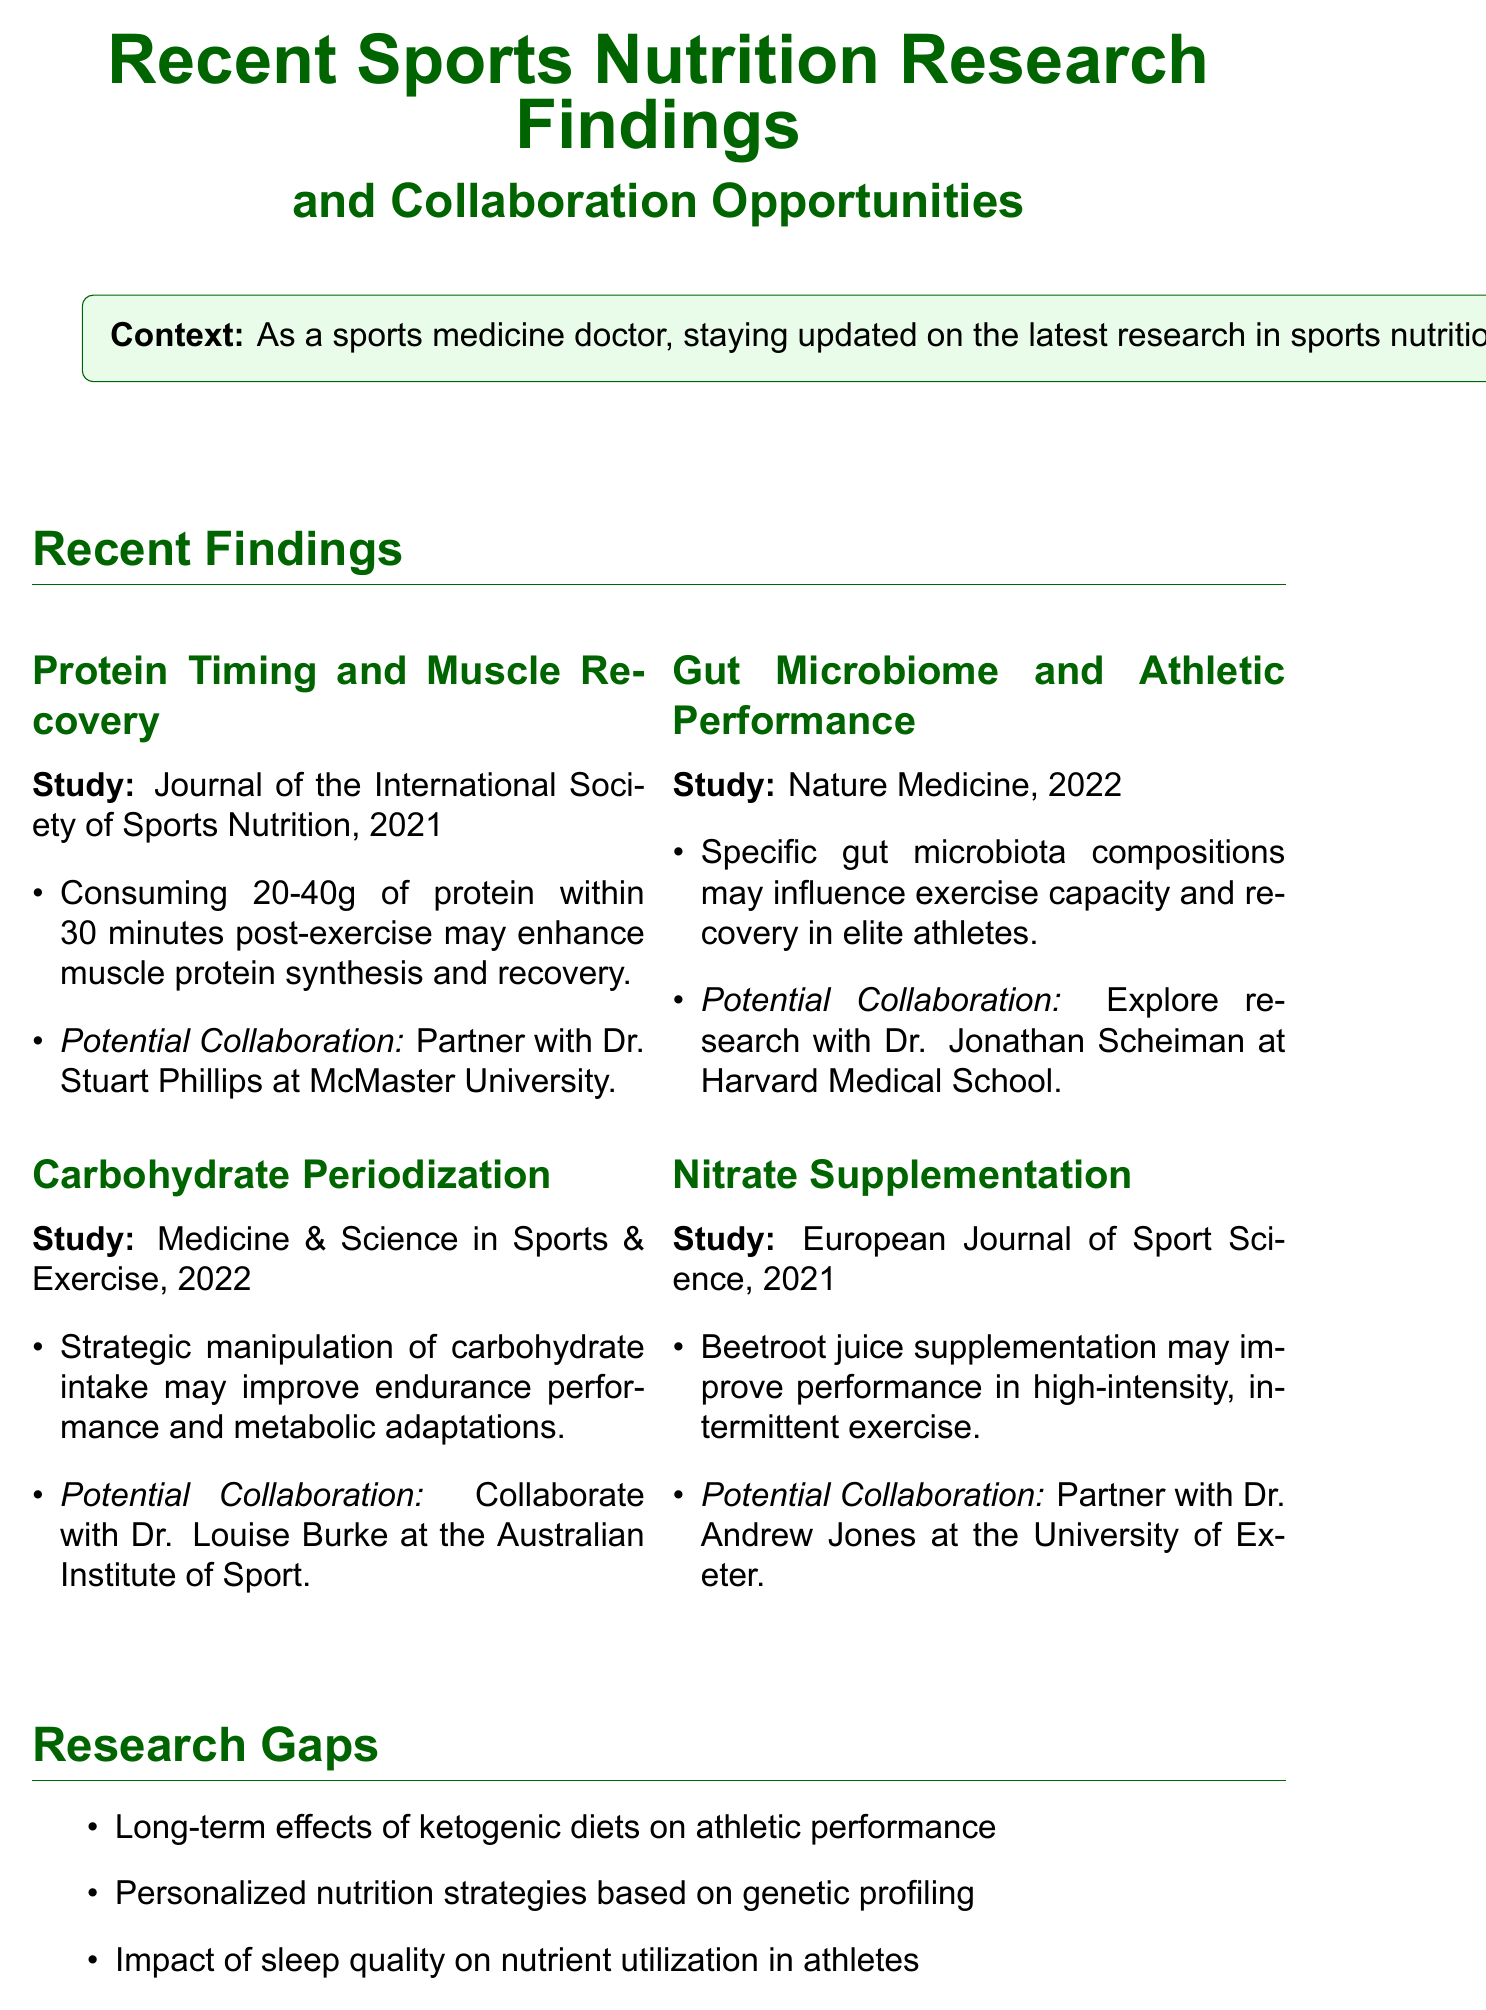what is the title of the memo? The title of the memo is indicated at the top of the document.
Answer: Recent Sports Nutrition Research Findings and Collaboration Opportunities who authored the study on protein timing and muscle recovery? The study on protein timing and muscle recovery is published in the Journal of the International Society of Sports Nutrition.
Answer: Journal of the International Society of Sports Nutrition what is the recommended amount of protein to consume post-exercise according to the memo? The memo specifies the recommended amount of protein consumption post-exercise.
Answer: 20-40g which institution is associated with research on hydration strategies? The memo lists institutions for collaboration opportunities, including those focused on hydration strategies.
Answer: Gatorade Sports Science Institute what research focus is associated with Dr. Louise Burke? The potential collaboration section specifies Dr. Louise Burke's research focus area.
Answer: Carbohydrate periodization in team sports identify one research gap mentioned in the memo. The memo outlines several research gaps in sports nutrition.
Answer: Long-term effects of ketogenic diets on athletic performance what is a potential collaboration mentioned in relation to the gut microbiome? The memo indicates potential collaboration opportunities regarding the gut microbiome and athletic performance.
Answer: Dr. Jonathan Scheiman at Harvard Medical School how many significant recent findings are summarized in the memo? The number of recent findings is specified within the content of the memo.
Answer: Four 